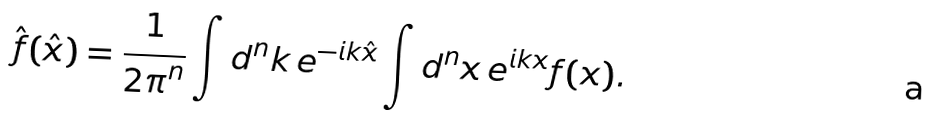Convert formula to latex. <formula><loc_0><loc_0><loc_500><loc_500>\hat { f } ( \hat { x } ) = \frac { 1 } { { 2 \pi } ^ { n } } \int d ^ { n } k \, e ^ { - i k \hat { x } } \int d ^ { n } x \, e ^ { i k x } f ( x ) .</formula> 